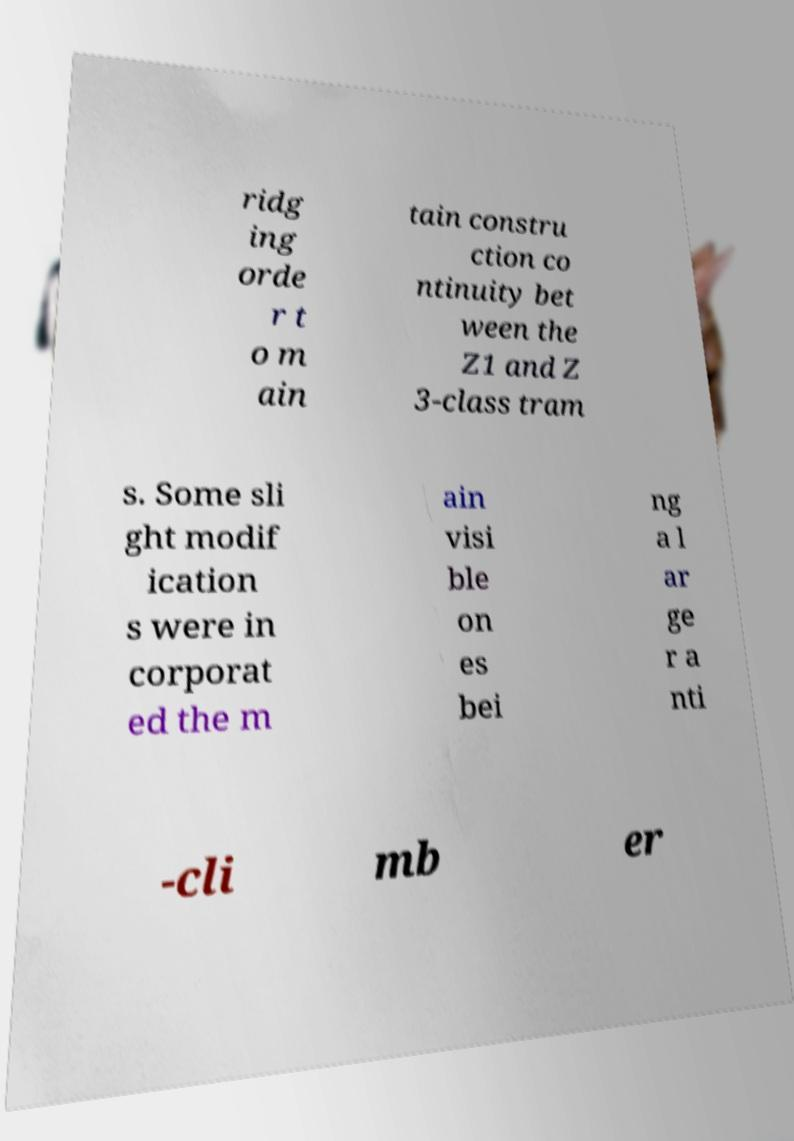There's text embedded in this image that I need extracted. Can you transcribe it verbatim? ridg ing orde r t o m ain tain constru ction co ntinuity bet ween the Z1 and Z 3-class tram s. Some sli ght modif ication s were in corporat ed the m ain visi ble on es bei ng a l ar ge r a nti -cli mb er 